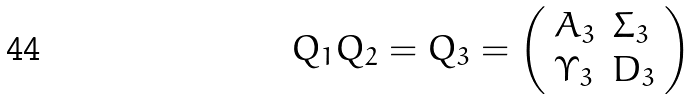<formula> <loc_0><loc_0><loc_500><loc_500>Q _ { 1 } Q _ { 2 } = Q _ { 3 } = \left ( \begin{array} { l l } A _ { 3 } & \Sigma _ { 3 } \\ \Upsilon _ { 3 } & D _ { 3 } \end{array} \right )</formula> 